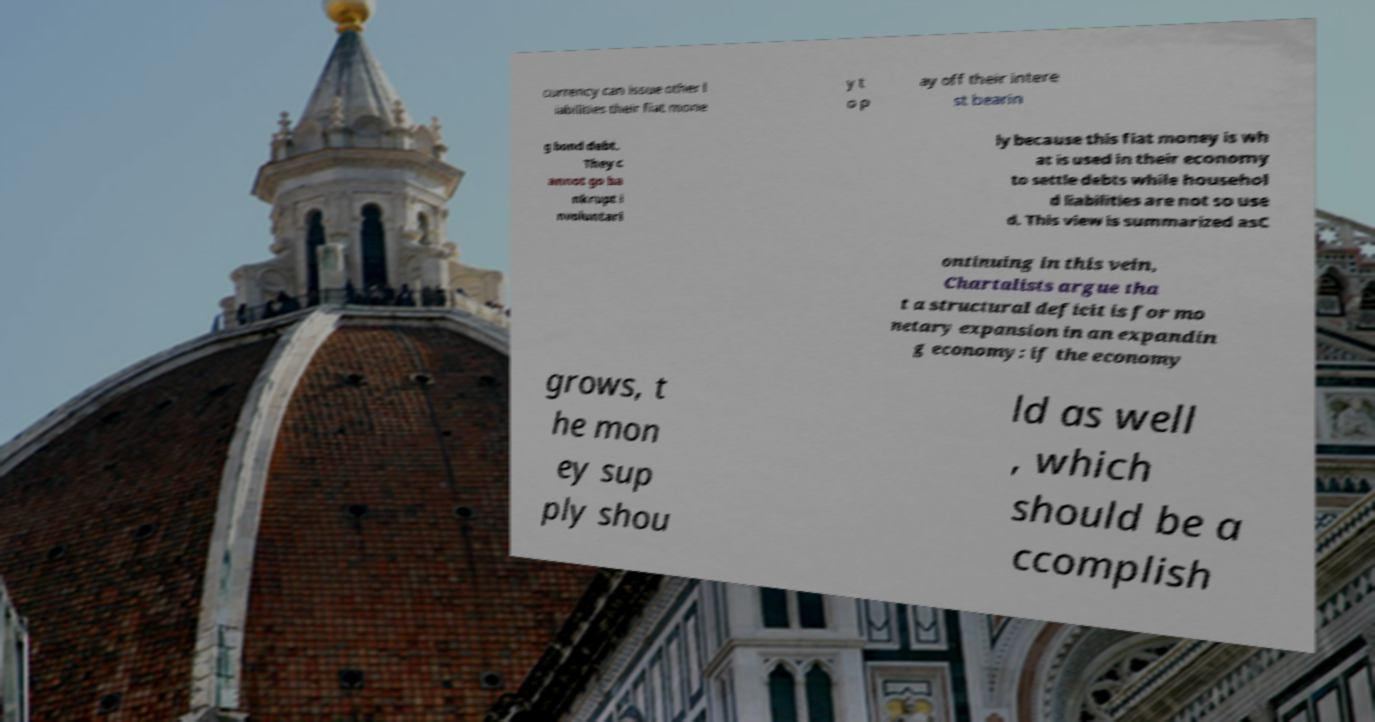Can you read and provide the text displayed in the image?This photo seems to have some interesting text. Can you extract and type it out for me? currency can issue other l iabilities their fiat mone y t o p ay off their intere st bearin g bond debt. They c annot go ba nkrupt i nvoluntari ly because this fiat money is wh at is used in their economy to settle debts while househol d liabilities are not so use d. This view is summarized asC ontinuing in this vein, Chartalists argue tha t a structural deficit is for mo netary expansion in an expandin g economy: if the economy grows, t he mon ey sup ply shou ld as well , which should be a ccomplish 